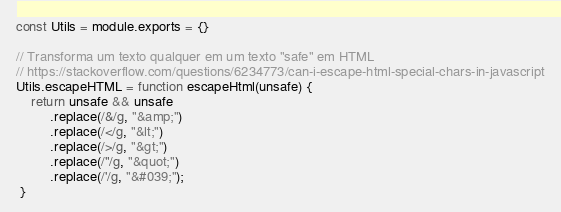<code> <loc_0><loc_0><loc_500><loc_500><_JavaScript_>
const Utils = module.exports = {}

// Transforma um texto qualquer em um texto "safe" em HTML
// https://stackoverflow.com/questions/6234773/can-i-escape-html-special-chars-in-javascript
Utils.escapeHTML = function escapeHtml(unsafe) {
    return unsafe && unsafe
         .replace(/&/g, "&amp;")
         .replace(/</g, "&lt;")
         .replace(/>/g, "&gt;")
         .replace(/"/g, "&quot;")
         .replace(/'/g, "&#039;");
 }</code> 